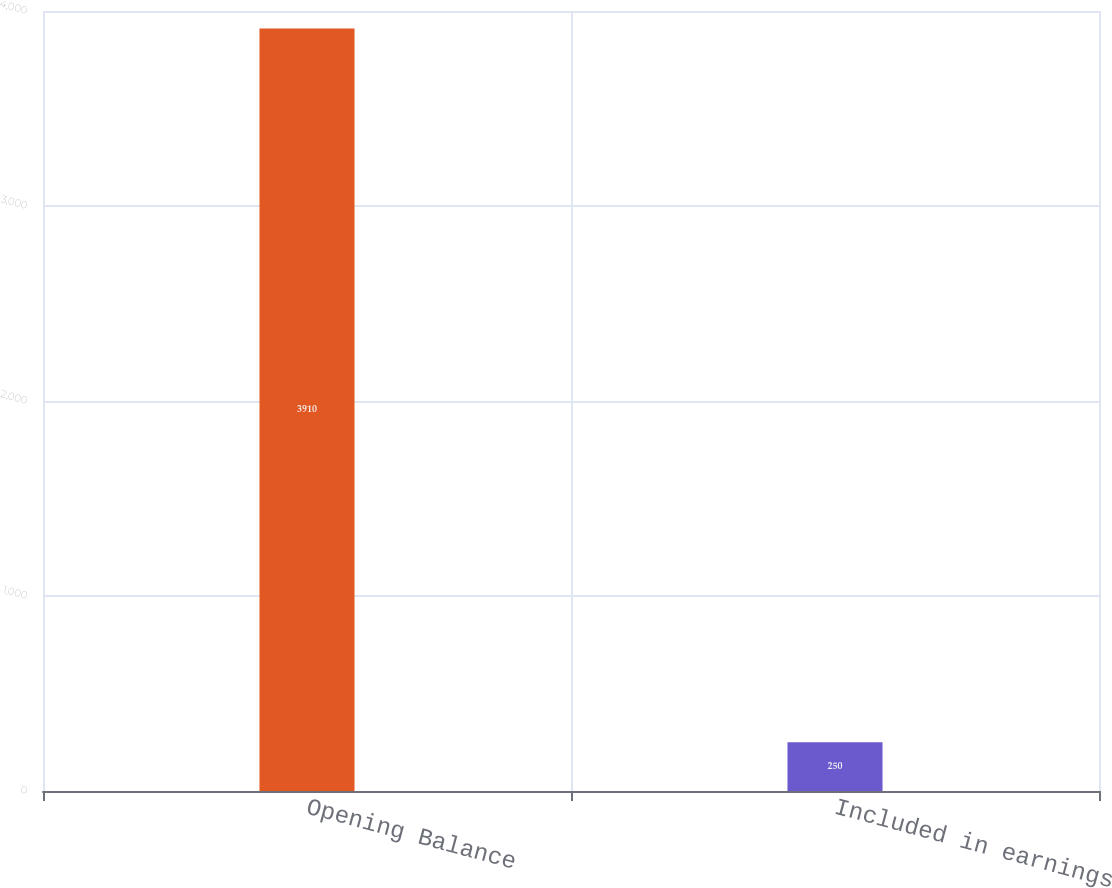<chart> <loc_0><loc_0><loc_500><loc_500><bar_chart><fcel>Opening Balance<fcel>Included in earnings<nl><fcel>3910<fcel>250<nl></chart> 